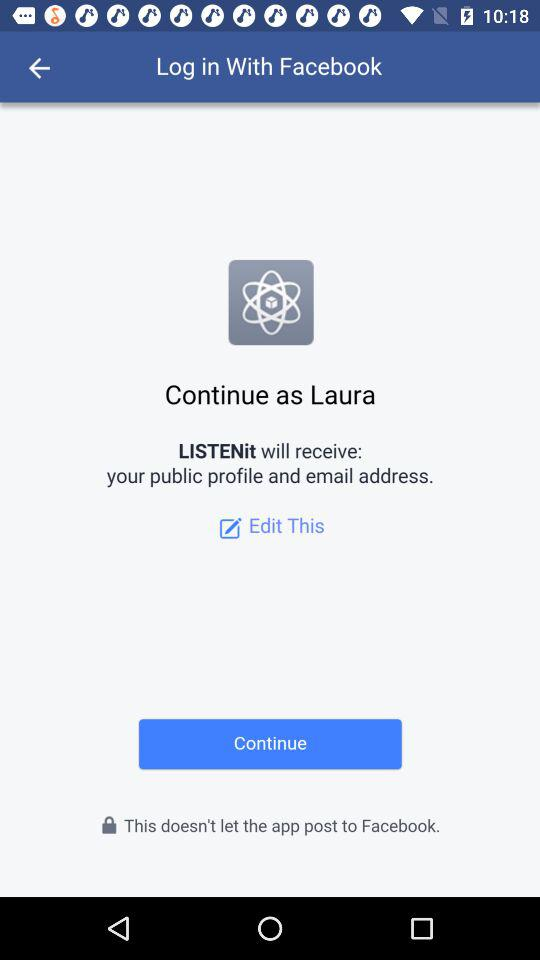What application is asking for permission? The application asking for permission is "LISTENit". 